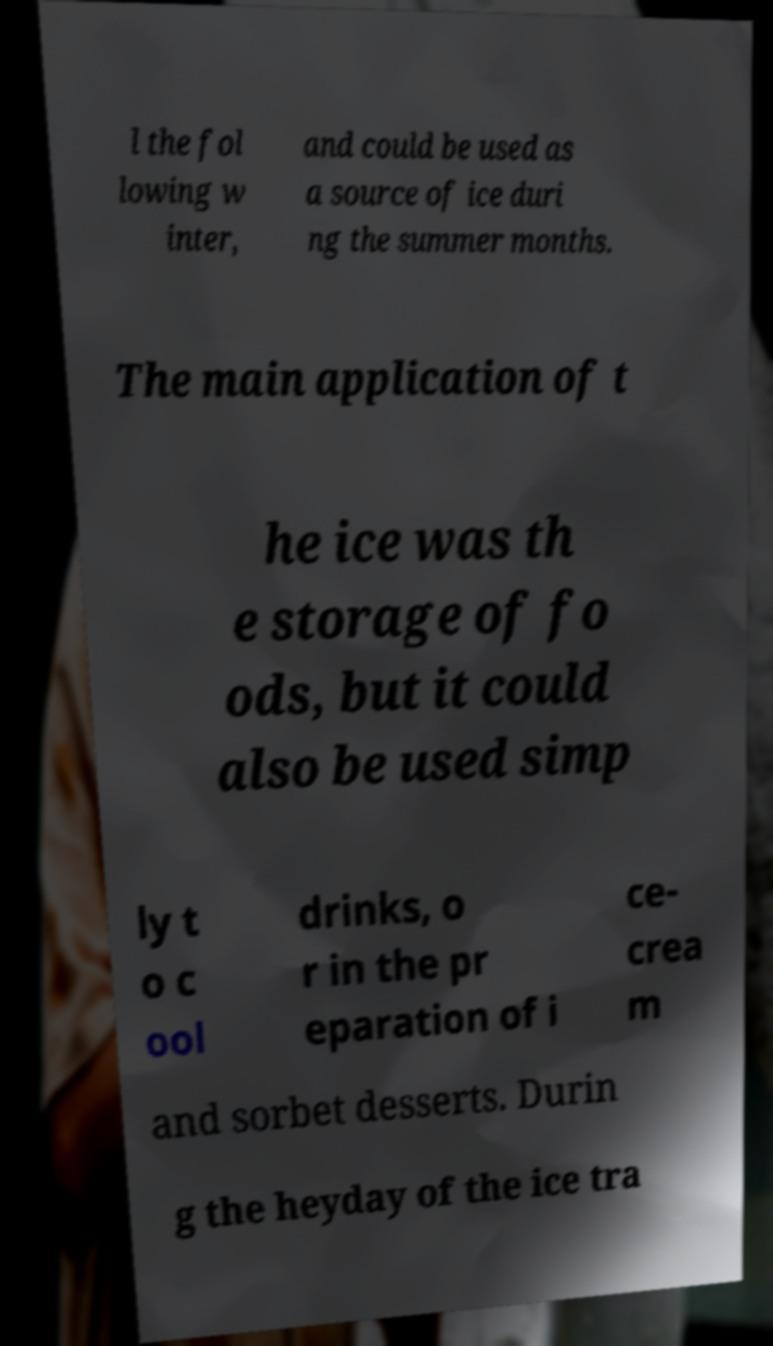What messages or text are displayed in this image? I need them in a readable, typed format. l the fol lowing w inter, and could be used as a source of ice duri ng the summer months. The main application of t he ice was th e storage of fo ods, but it could also be used simp ly t o c ool drinks, o r in the pr eparation of i ce- crea m and sorbet desserts. Durin g the heyday of the ice tra 